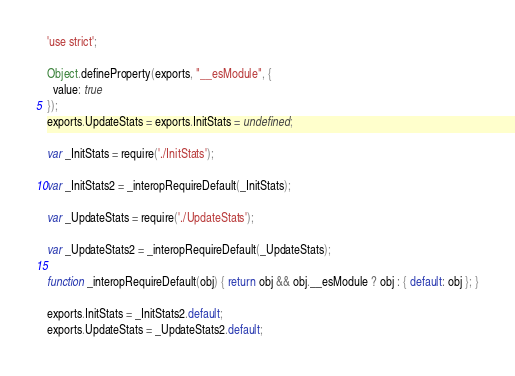<code> <loc_0><loc_0><loc_500><loc_500><_JavaScript_>'use strict';

Object.defineProperty(exports, "__esModule", {
  value: true
});
exports.UpdateStats = exports.InitStats = undefined;

var _InitStats = require('./InitStats');

var _InitStats2 = _interopRequireDefault(_InitStats);

var _UpdateStats = require('./UpdateStats');

var _UpdateStats2 = _interopRequireDefault(_UpdateStats);

function _interopRequireDefault(obj) { return obj && obj.__esModule ? obj : { default: obj }; }

exports.InitStats = _InitStats2.default;
exports.UpdateStats = _UpdateStats2.default;</code> 